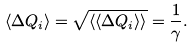<formula> <loc_0><loc_0><loc_500><loc_500>\langle \Delta Q _ { i } \rangle = \sqrt { \langle \langle \Delta Q _ { i } \rangle \rangle } = \frac { 1 } { \gamma } .</formula> 